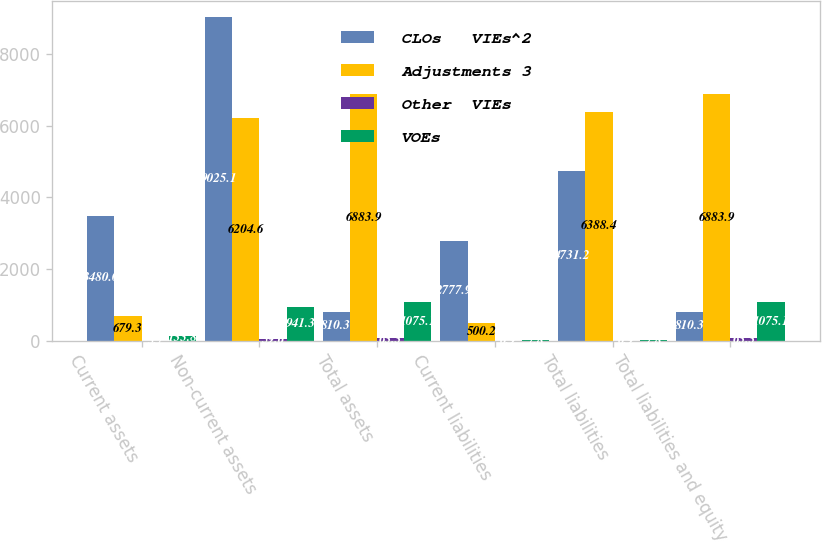Convert chart to OTSL. <chart><loc_0><loc_0><loc_500><loc_500><stacked_bar_chart><ecel><fcel>Current assets<fcel>Non-current assets<fcel>Total assets<fcel>Current liabilities<fcel>Total liabilities<fcel>Total liabilities and equity<nl><fcel>CLOs   VIEs^2<fcel>3480<fcel>9025.1<fcel>810.3<fcel>2777.9<fcel>4731.2<fcel>810.3<nl><fcel>Adjustments 3<fcel>679.3<fcel>6204.6<fcel>6883.9<fcel>500.2<fcel>6388.4<fcel>6883.9<nl><fcel>Other  VIEs<fcel>3.7<fcel>59.6<fcel>63.3<fcel>0.9<fcel>0.9<fcel>63.3<nl><fcel>VOEs<fcel>133.8<fcel>941.3<fcel>1075.1<fcel>7.8<fcel>7.8<fcel>1075.1<nl></chart> 